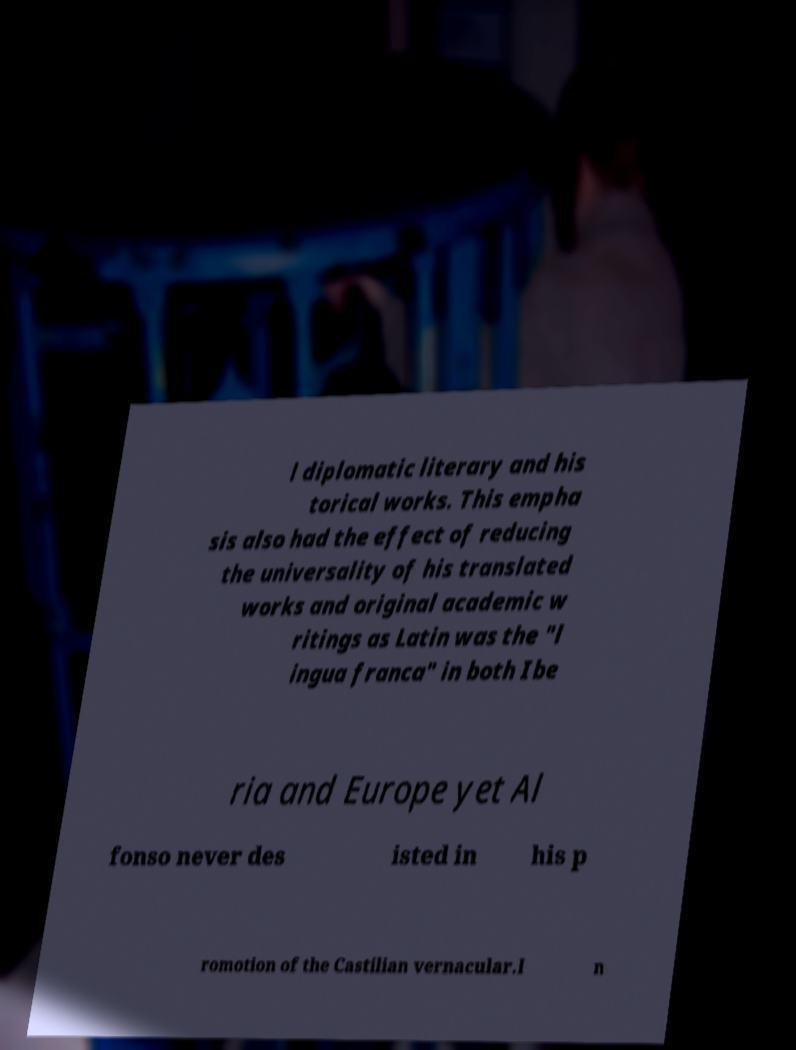For documentation purposes, I need the text within this image transcribed. Could you provide that? l diplomatic literary and his torical works. This empha sis also had the effect of reducing the universality of his translated works and original academic w ritings as Latin was the "l ingua franca" in both Ibe ria and Europe yet Al fonso never des isted in his p romotion of the Castilian vernacular.I n 